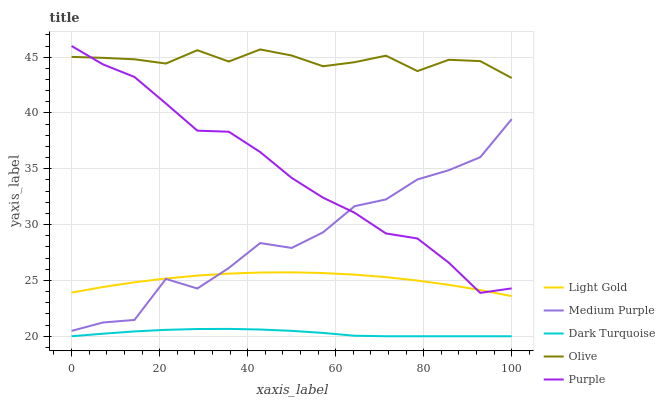Does Dark Turquoise have the minimum area under the curve?
Answer yes or no. Yes. Does Olive have the maximum area under the curve?
Answer yes or no. Yes. Does Light Gold have the minimum area under the curve?
Answer yes or no. No. Does Light Gold have the maximum area under the curve?
Answer yes or no. No. Is Dark Turquoise the smoothest?
Answer yes or no. Yes. Is Medium Purple the roughest?
Answer yes or no. Yes. Is Light Gold the smoothest?
Answer yes or no. No. Is Light Gold the roughest?
Answer yes or no. No. Does Dark Turquoise have the lowest value?
Answer yes or no. Yes. Does Light Gold have the lowest value?
Answer yes or no. No. Does Purple have the highest value?
Answer yes or no. Yes. Does Light Gold have the highest value?
Answer yes or no. No. Is Dark Turquoise less than Olive?
Answer yes or no. Yes. Is Olive greater than Medium Purple?
Answer yes or no. Yes. Does Medium Purple intersect Light Gold?
Answer yes or no. Yes. Is Medium Purple less than Light Gold?
Answer yes or no. No. Is Medium Purple greater than Light Gold?
Answer yes or no. No. Does Dark Turquoise intersect Olive?
Answer yes or no. No. 